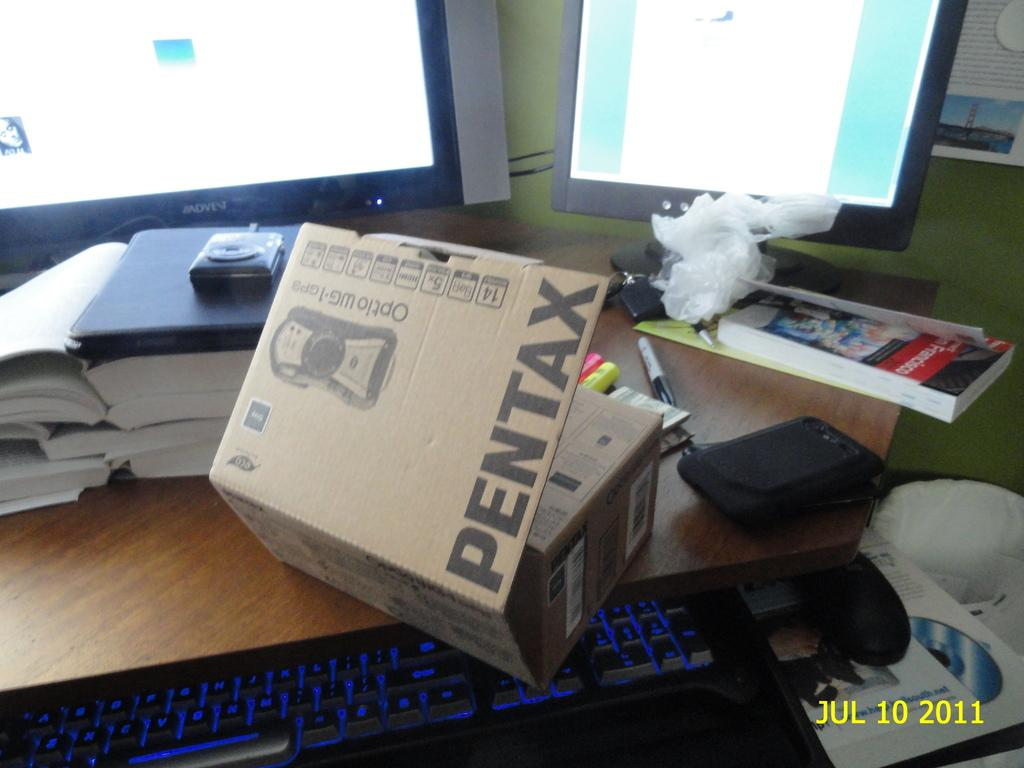<image>
Describe the image concisely. Brown Pentax box on top of a table with computer monitors. 